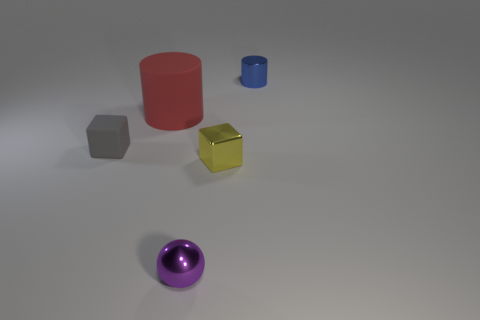What is the material of the purple object that is the same size as the matte cube?
Your answer should be compact. Metal. There is another small thing that is the same shape as the red rubber thing; what material is it?
Keep it short and to the point. Metal. There is a cylinder on the left side of the tiny shiny cylinder; how big is it?
Your response must be concise. Large. There is a tiny object behind the cylinder that is in front of the tiny metallic thing that is behind the big red matte cylinder; what shape is it?
Offer a terse response. Cylinder. How many other objects are there of the same shape as the red rubber object?
Your response must be concise. 1. How many metal things are gray balls or tiny yellow blocks?
Make the answer very short. 1. The thing that is to the left of the cylinder in front of the blue metal cylinder is made of what material?
Your response must be concise. Rubber. Is the number of tiny gray matte blocks left of the big red cylinder greater than the number of green metallic objects?
Your answer should be compact. Yes. Are there any red objects that have the same material as the ball?
Provide a succinct answer. No. There is a thing on the right side of the yellow thing; does it have the same shape as the small purple object?
Provide a succinct answer. No. 